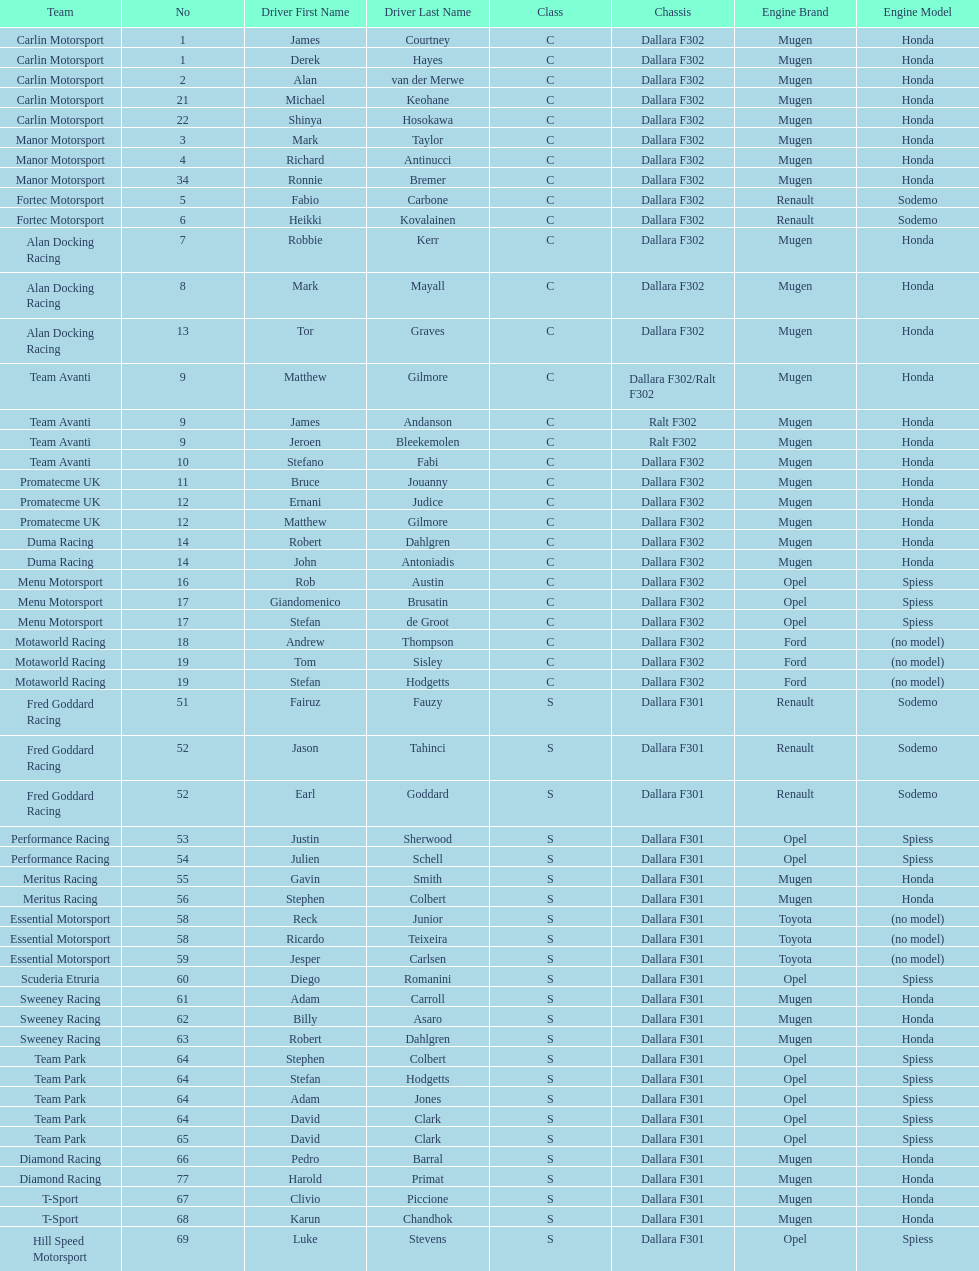What is the average number of teams that had a mugen-honda engine? 24. 